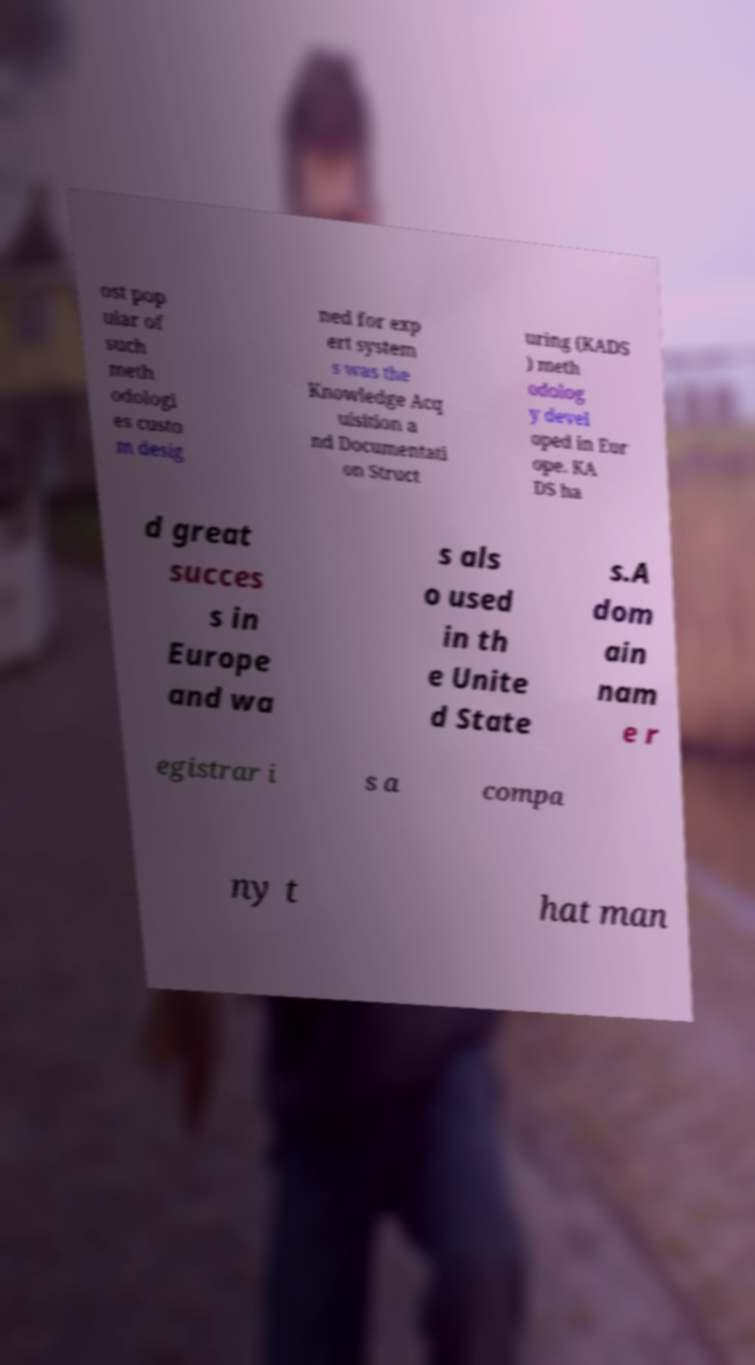Can you accurately transcribe the text from the provided image for me? ost pop ular of such meth odologi es custo m desig ned for exp ert system s was the Knowledge Acq uisition a nd Documentati on Struct uring (KADS ) meth odolog y devel oped in Eur ope. KA DS ha d great succes s in Europe and wa s als o used in th e Unite d State s.A dom ain nam e r egistrar i s a compa ny t hat man 